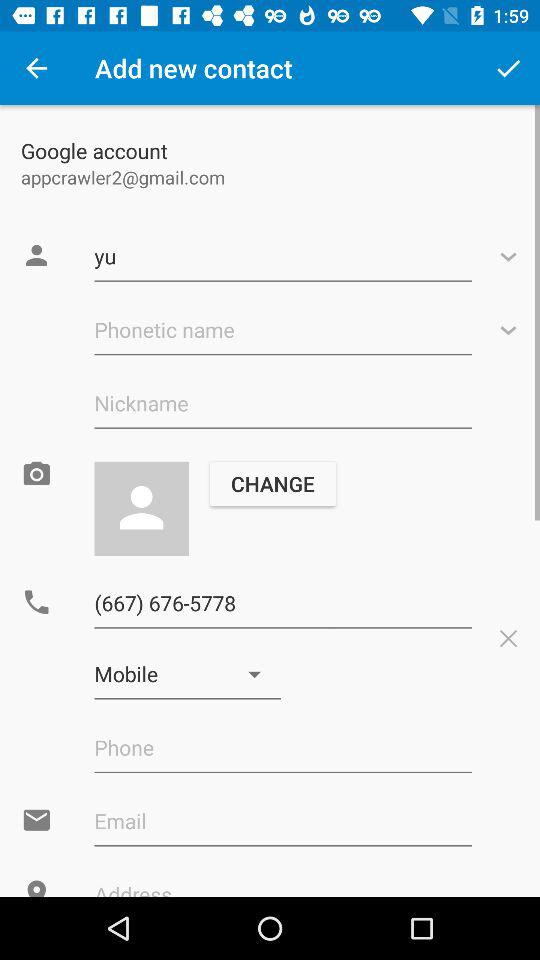What is the contact number? The contact number is (667) 676-5778. 